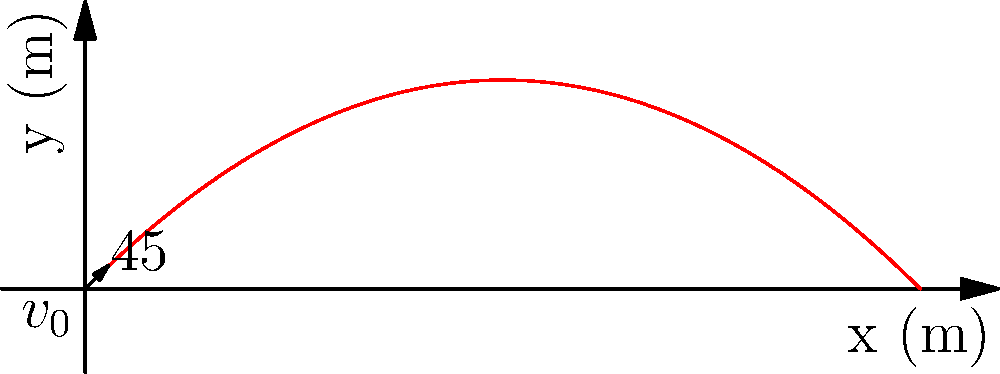A projectile is launched from ground level with an initial velocity of 50 m/s at a 45° angle to the horizontal. Assuming air resistance is negligible, at what time does the projectile reach its maximum height? How might understanding this concept contribute to designing mental agility games that enhance spatial reasoning and predictive skills? To solve this problem, we'll follow these steps:

1) The vertical component of velocity ($v_y$) at the highest point is zero.
2) Initial vertical velocity: $v_{0y} = v_0 \sin(\theta)$
3) Using the equation $v_y = v_{0y} - gt$, where $g$ is the acceleration due to gravity (9.8 m/s²)

Step 1: Calculate the initial vertical velocity
$v_{0y} = 50 \sin(45°) = 50 \cdot \frac{\sqrt{2}}{2} = 35.36$ m/s

Step 2: Set up the equation for vertical velocity at the highest point
$0 = 35.36 - 9.8t$

Step 3: Solve for time
$t = \frac{35.36}{9.8} = 3.61$ seconds

This concept contributes to mental agility games by:
1) Enhancing spatial reasoning: Players visualize the projectile's path in 2D space.
2) Developing predictive skills: Players estimate the time and position of the projectile at its peak.
3) Improving mathematical thinking: Players apply physics equations to real-world scenarios.
4) Boosting problem-solving abilities: Players break down complex problems into manageable steps.

These skills are crucial for cognitive development and can be incorporated into games that challenge players to predict trajectories, intercept projectiles, or optimize launch angles for specific targets.
Answer: 3.61 seconds 